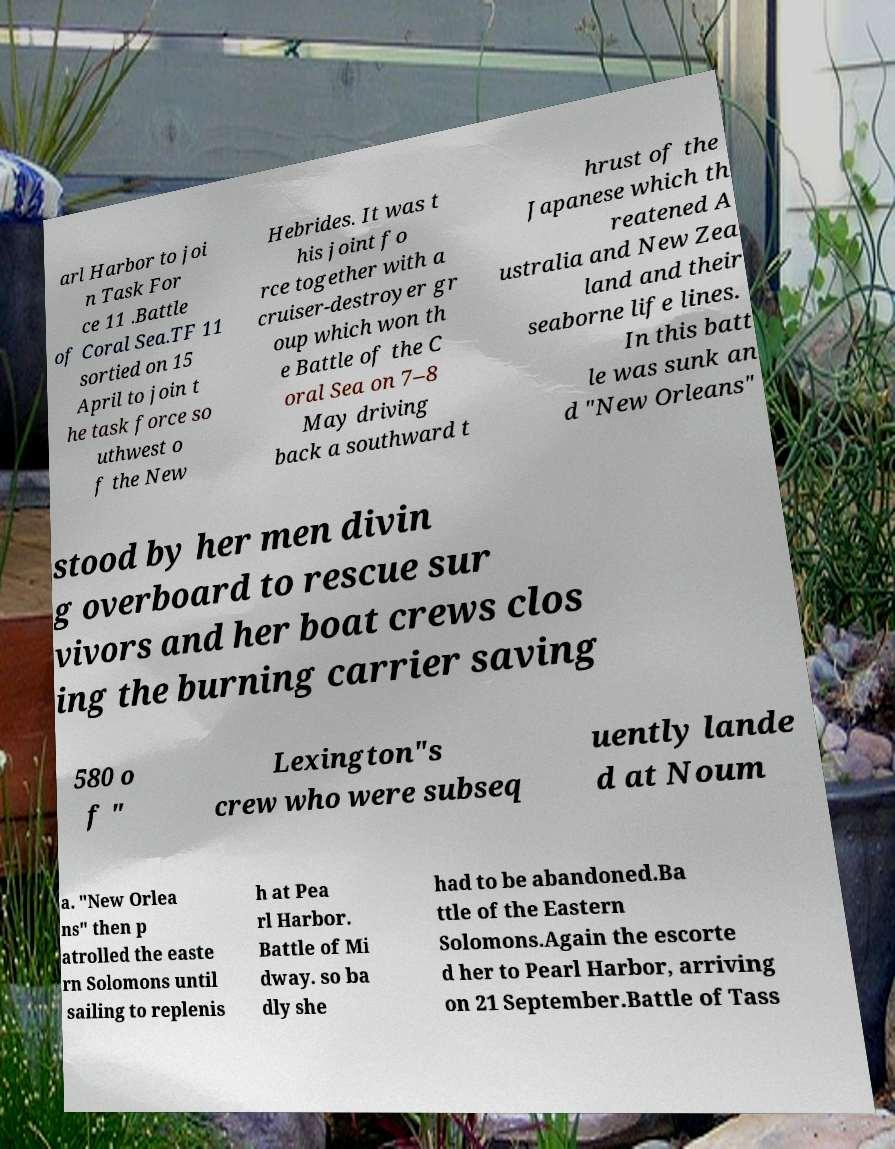Can you read and provide the text displayed in the image?This photo seems to have some interesting text. Can you extract and type it out for me? arl Harbor to joi n Task For ce 11 .Battle of Coral Sea.TF 11 sortied on 15 April to join t he task force so uthwest o f the New Hebrides. It was t his joint fo rce together with a cruiser-destroyer gr oup which won th e Battle of the C oral Sea on 7–8 May driving back a southward t hrust of the Japanese which th reatened A ustralia and New Zea land and their seaborne life lines. In this batt le was sunk an d "New Orleans" stood by her men divin g overboard to rescue sur vivors and her boat crews clos ing the burning carrier saving 580 o f " Lexington"s crew who were subseq uently lande d at Noum a. "New Orlea ns" then p atrolled the easte rn Solomons until sailing to replenis h at Pea rl Harbor. Battle of Mi dway. so ba dly she had to be abandoned.Ba ttle of the Eastern Solomons.Again the escorte d her to Pearl Harbor, arriving on 21 September.Battle of Tass 